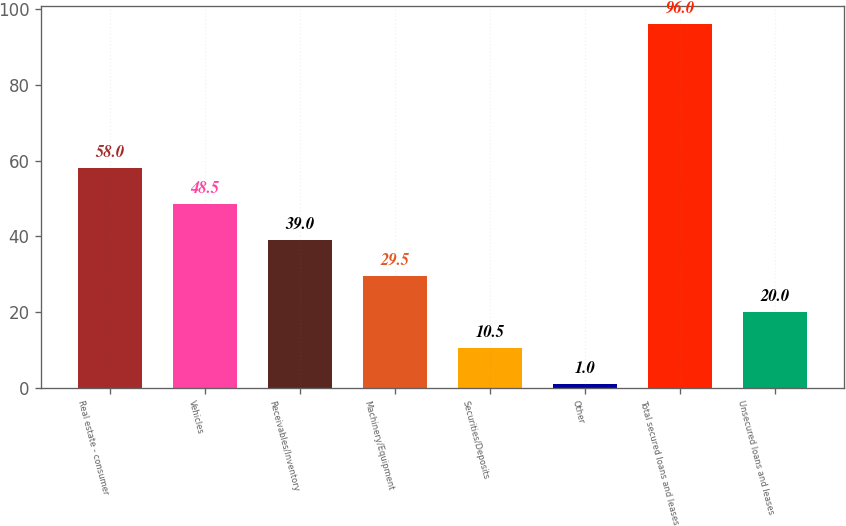Convert chart. <chart><loc_0><loc_0><loc_500><loc_500><bar_chart><fcel>Real estate - consumer<fcel>Vehicles<fcel>Receivables/Inventory<fcel>Machinery/Equipment<fcel>Securities/Deposits<fcel>Other<fcel>Total secured loans and leases<fcel>Unsecured loans and leases<nl><fcel>58<fcel>48.5<fcel>39<fcel>29.5<fcel>10.5<fcel>1<fcel>96<fcel>20<nl></chart> 